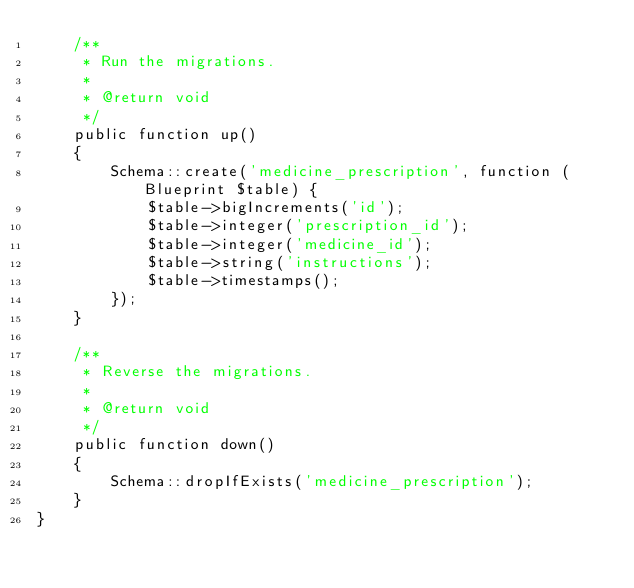<code> <loc_0><loc_0><loc_500><loc_500><_PHP_>    /**
     * Run the migrations.
     *
     * @return void
     */
    public function up()
    {
        Schema::create('medicine_prescription', function (Blueprint $table) {
            $table->bigIncrements('id');
            $table->integer('prescription_id');
            $table->integer('medicine_id');
            $table->string('instructions');
            $table->timestamps();
        });
    }

    /**
     * Reverse the migrations.
     *
     * @return void
     */
    public function down()
    {
        Schema::dropIfExists('medicine_prescription');
    }
}
</code> 